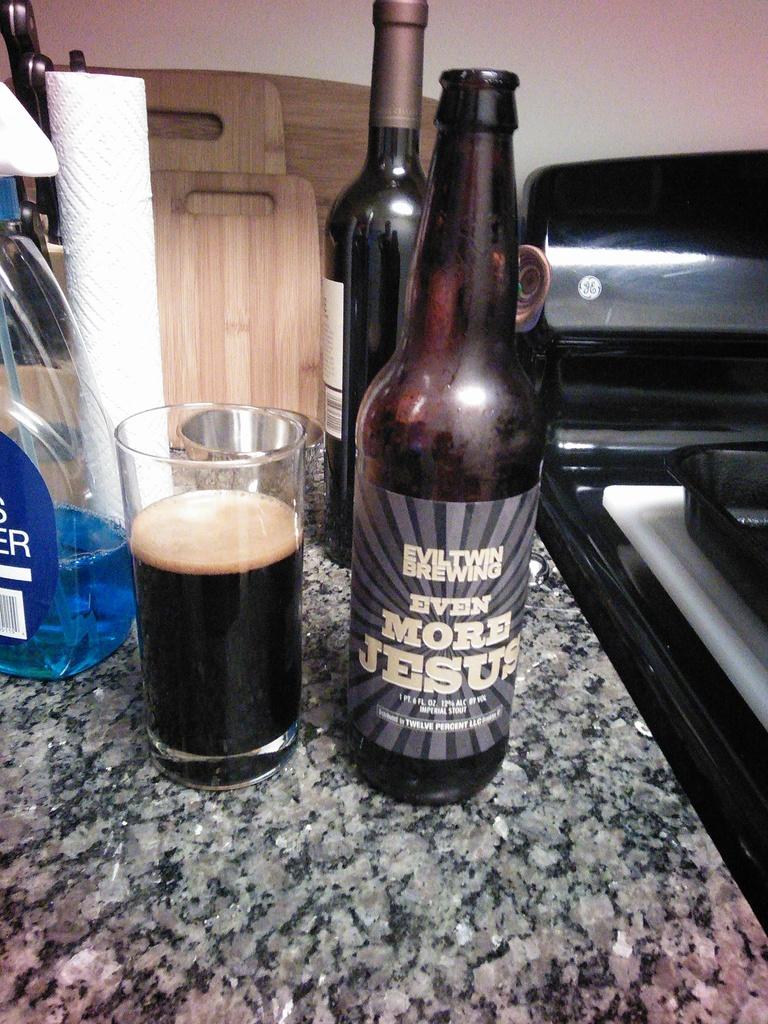What is the name of this drink?
Your response must be concise. Even more jesus. 